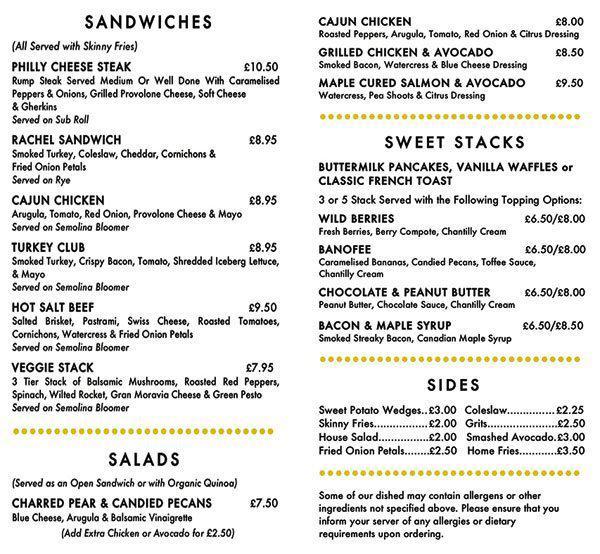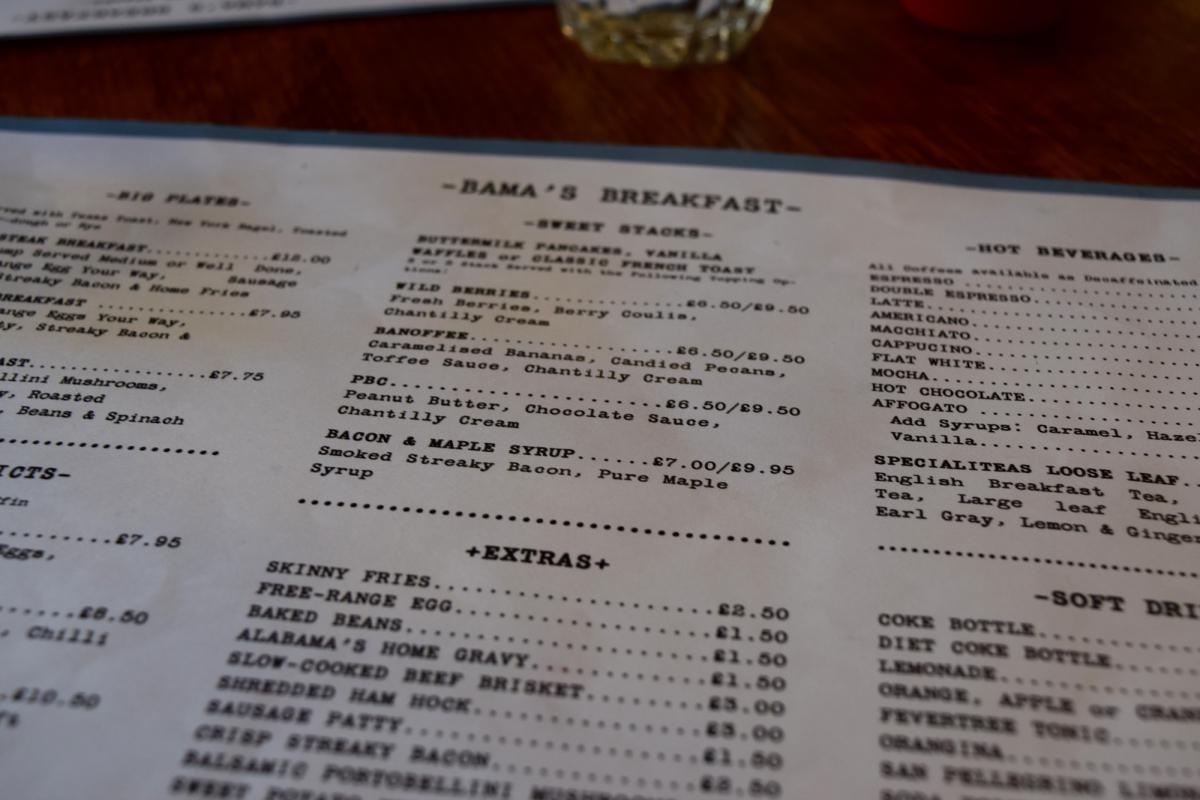The first image is the image on the left, the second image is the image on the right. Assess this claim about the two images: "There are exactly two menus.". Correct or not? Answer yes or no. Yes. 